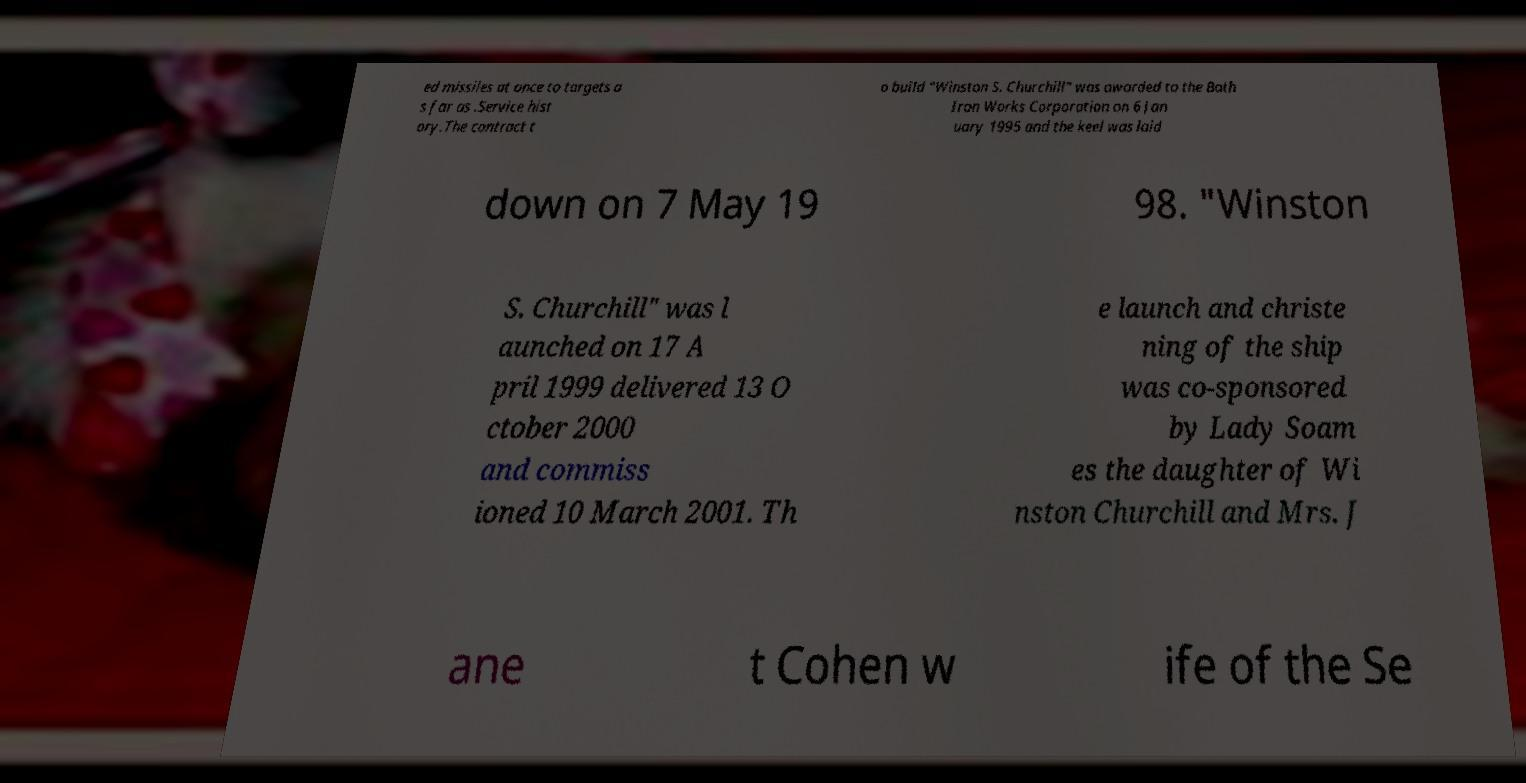Could you assist in decoding the text presented in this image and type it out clearly? ed missiles at once to targets a s far as .Service hist ory.The contract t o build "Winston S. Churchill" was awarded to the Bath Iron Works Corporation on 6 Jan uary 1995 and the keel was laid down on 7 May 19 98. "Winston S. Churchill" was l aunched on 17 A pril 1999 delivered 13 O ctober 2000 and commiss ioned 10 March 2001. Th e launch and christe ning of the ship was co-sponsored by Lady Soam es the daughter of Wi nston Churchill and Mrs. J ane t Cohen w ife of the Se 